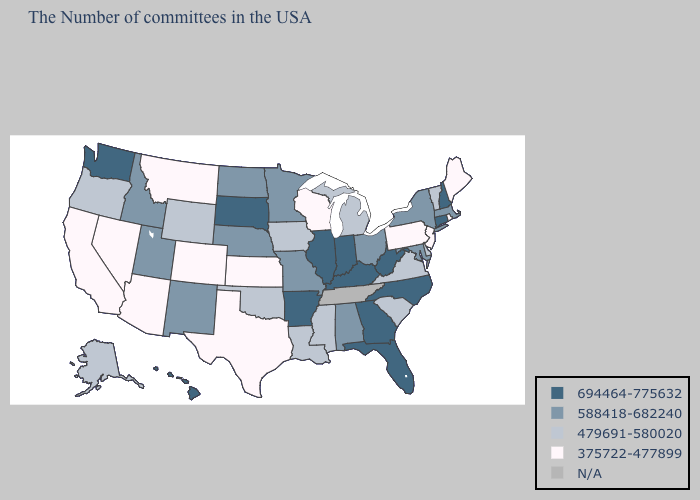Does North Carolina have the lowest value in the USA?
Concise answer only. No. What is the value of Delaware?
Quick response, please. 479691-580020. Does Washington have the highest value in the West?
Answer briefly. Yes. Does Kentucky have the highest value in the USA?
Concise answer only. Yes. Is the legend a continuous bar?
Be succinct. No. What is the value of Kentucky?
Short answer required. 694464-775632. Is the legend a continuous bar?
Short answer required. No. Name the states that have a value in the range 588418-682240?
Short answer required. Massachusetts, New York, Maryland, Ohio, Alabama, Missouri, Minnesota, Nebraska, North Dakota, New Mexico, Utah, Idaho. Which states have the highest value in the USA?
Short answer required. New Hampshire, Connecticut, North Carolina, West Virginia, Florida, Georgia, Kentucky, Indiana, Illinois, Arkansas, South Dakota, Washington, Hawaii. Among the states that border Vermont , which have the highest value?
Keep it brief. New Hampshire. Which states have the lowest value in the South?
Keep it brief. Texas. Does Massachusetts have the lowest value in the Northeast?
Answer briefly. No. 